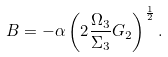Convert formula to latex. <formula><loc_0><loc_0><loc_500><loc_500>B = - \alpha \left ( 2 \frac { \Omega _ { 3 } } { \Sigma _ { 3 } } G _ { 2 } \right ) ^ { \frac { 1 } { 2 } } .</formula> 